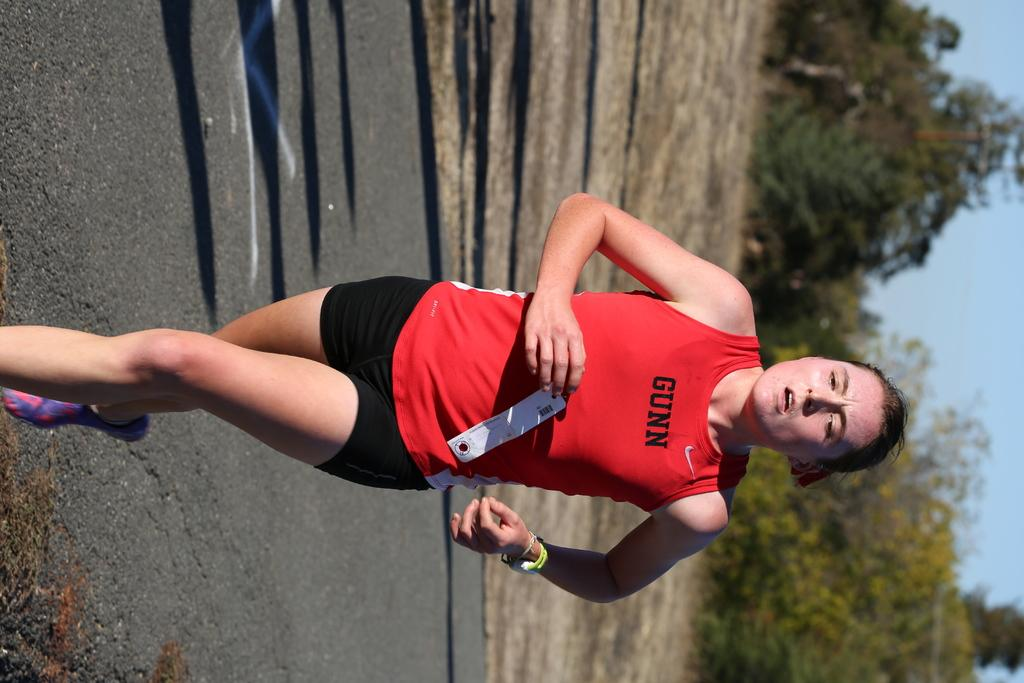<image>
Render a clear and concise summary of the photo. a person that has the word Gunn on their shirt 